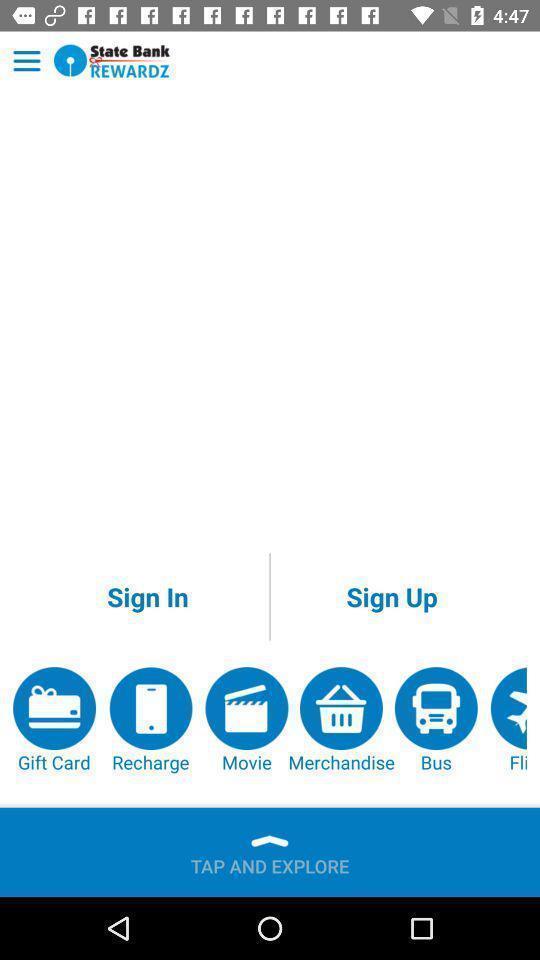Describe the visual elements of this screenshot. Welcome page of banking application. 